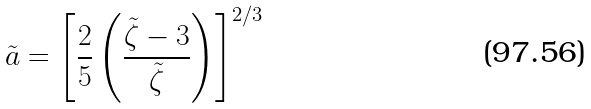Convert formula to latex. <formula><loc_0><loc_0><loc_500><loc_500>\tilde { a } = \left [ \frac { 2 } { 5 } \left ( \frac { \tilde { \zeta } - 3 } { \tilde { \zeta } } \right ) \right ] ^ { 2 / 3 }</formula> 